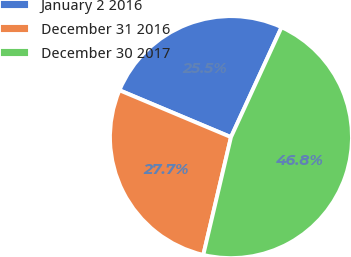<chart> <loc_0><loc_0><loc_500><loc_500><pie_chart><fcel>January 2 2016<fcel>December 31 2016<fcel>December 30 2017<nl><fcel>25.53%<fcel>27.66%<fcel>46.81%<nl></chart> 